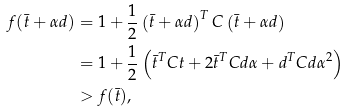Convert formula to latex. <formula><loc_0><loc_0><loc_500><loc_500>f ( \bar { t } + \alpha d ) & = 1 + \frac { 1 } { 2 } \left ( \bar { t } + \alpha d \right ) ^ { T } C \left ( \bar { t } + \alpha d \right ) \\ & = 1 + \frac { 1 } { 2 } \left ( \bar { t } ^ { T } C t + 2 \bar { t } ^ { T } C d \alpha + d ^ { T } C d \alpha ^ { 2 } \right ) \\ & > f ( \bar { t } ) ,</formula> 